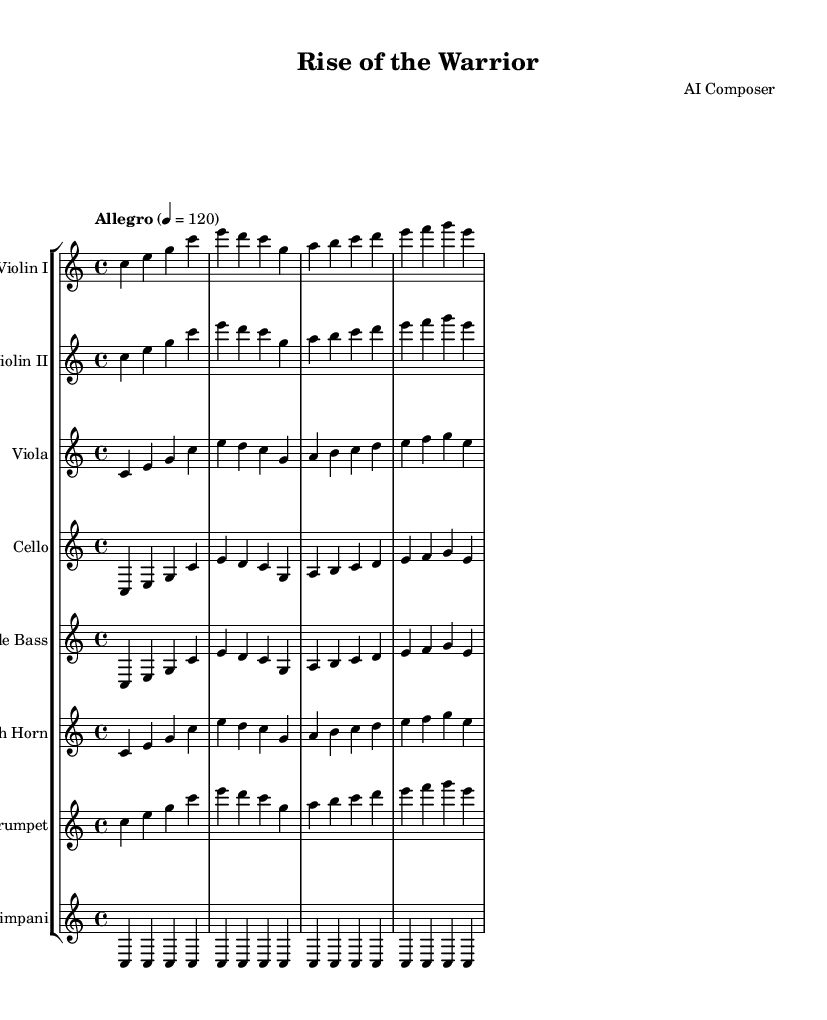What is the key signature of this music? The key signature is C major, which is indicated at the beginning of the score and has no sharps or flats.
Answer: C major What is the time signature of this piece? The time signature is found next to the key signature at the beginning and is specified as 4/4, indicating four beats per measure.
Answer: 4/4 What is the tempo marking for this Symphony? The tempo marking is displayed at the beginning of the score, indicating "Allegro" with a metronome marking of 120 beats per minute.
Answer: Allegro, 120 How many instruments are in this Symphony? By counting the individual staves in the score, we see there are eight instruments: Violin I, Violin II, Viola, Cello, Double Bass, French Horn, Trumpet, and Timpani.
Answer: Eight Which instrument plays the melody in this excerpt? The violins (I and II) are typically the lead instruments and play the main melody throughout the piece, as indicated by their prominent notes.
Answer: Violin I and II How many measures are in the provided score? By counting the measures in each staff, we find that there are four measures shown for each instrument, making a total of four measures.
Answer: Four What texture does the Symphony create with multiple instruments? The Symphony creates a rich, layered texture known as homophony, where multiple instruments play different notes in harmony, as seen in the arrangement.
Answer: Homophony 